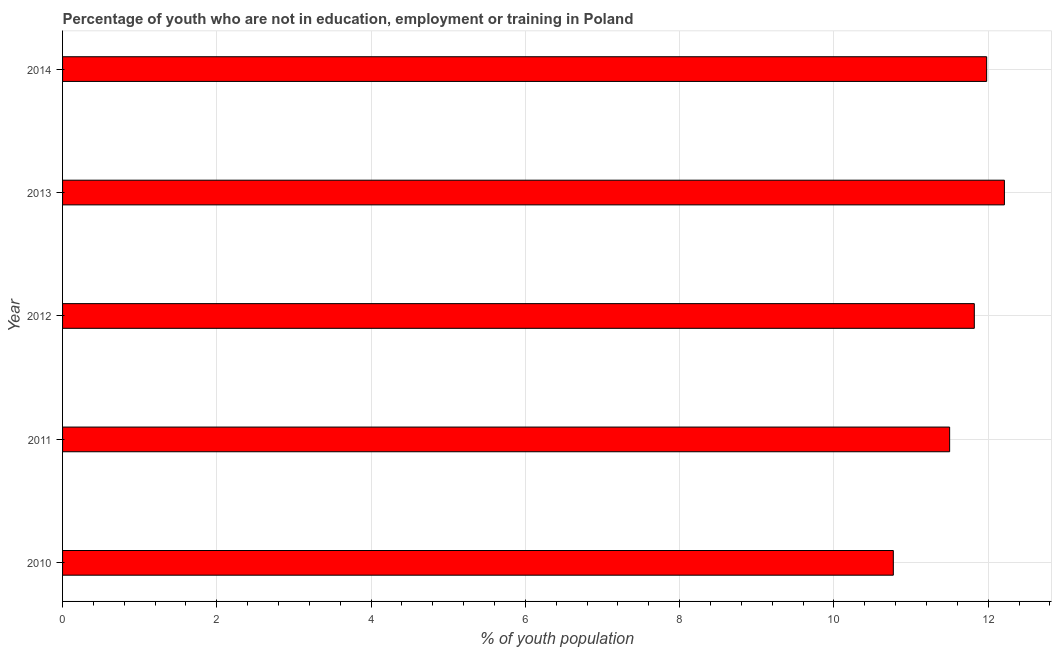Does the graph contain any zero values?
Make the answer very short. No. Does the graph contain grids?
Offer a terse response. Yes. What is the title of the graph?
Your answer should be compact. Percentage of youth who are not in education, employment or training in Poland. What is the label or title of the X-axis?
Provide a short and direct response. % of youth population. What is the label or title of the Y-axis?
Provide a succinct answer. Year. What is the unemployed youth population in 2013?
Provide a succinct answer. 12.21. Across all years, what is the maximum unemployed youth population?
Offer a very short reply. 12.21. Across all years, what is the minimum unemployed youth population?
Offer a terse response. 10.77. In which year was the unemployed youth population minimum?
Offer a terse response. 2010. What is the sum of the unemployed youth population?
Your response must be concise. 58.28. What is the difference between the unemployed youth population in 2011 and 2013?
Ensure brevity in your answer.  -0.71. What is the average unemployed youth population per year?
Provide a short and direct response. 11.66. What is the median unemployed youth population?
Give a very brief answer. 11.82. What is the ratio of the unemployed youth population in 2012 to that in 2014?
Offer a very short reply. 0.99. What is the difference between the highest and the second highest unemployed youth population?
Your answer should be compact. 0.23. What is the difference between the highest and the lowest unemployed youth population?
Ensure brevity in your answer.  1.44. In how many years, is the unemployed youth population greater than the average unemployed youth population taken over all years?
Provide a succinct answer. 3. How many bars are there?
Ensure brevity in your answer.  5. Are all the bars in the graph horizontal?
Ensure brevity in your answer.  Yes. How many years are there in the graph?
Provide a succinct answer. 5. What is the difference between two consecutive major ticks on the X-axis?
Keep it short and to the point. 2. What is the % of youth population in 2010?
Make the answer very short. 10.77. What is the % of youth population of 2011?
Provide a short and direct response. 11.5. What is the % of youth population in 2012?
Your response must be concise. 11.82. What is the % of youth population in 2013?
Ensure brevity in your answer.  12.21. What is the % of youth population of 2014?
Give a very brief answer. 11.98. What is the difference between the % of youth population in 2010 and 2011?
Offer a terse response. -0.73. What is the difference between the % of youth population in 2010 and 2012?
Ensure brevity in your answer.  -1.05. What is the difference between the % of youth population in 2010 and 2013?
Your response must be concise. -1.44. What is the difference between the % of youth population in 2010 and 2014?
Give a very brief answer. -1.21. What is the difference between the % of youth population in 2011 and 2012?
Give a very brief answer. -0.32. What is the difference between the % of youth population in 2011 and 2013?
Give a very brief answer. -0.71. What is the difference between the % of youth population in 2011 and 2014?
Your response must be concise. -0.48. What is the difference between the % of youth population in 2012 and 2013?
Your response must be concise. -0.39. What is the difference between the % of youth population in 2012 and 2014?
Offer a terse response. -0.16. What is the difference between the % of youth population in 2013 and 2014?
Provide a succinct answer. 0.23. What is the ratio of the % of youth population in 2010 to that in 2011?
Keep it short and to the point. 0.94. What is the ratio of the % of youth population in 2010 to that in 2012?
Offer a very short reply. 0.91. What is the ratio of the % of youth population in 2010 to that in 2013?
Your response must be concise. 0.88. What is the ratio of the % of youth population in 2010 to that in 2014?
Make the answer very short. 0.9. What is the ratio of the % of youth population in 2011 to that in 2012?
Give a very brief answer. 0.97. What is the ratio of the % of youth population in 2011 to that in 2013?
Your answer should be compact. 0.94. What is the ratio of the % of youth population in 2012 to that in 2013?
Offer a terse response. 0.97. What is the ratio of the % of youth population in 2013 to that in 2014?
Give a very brief answer. 1.02. 